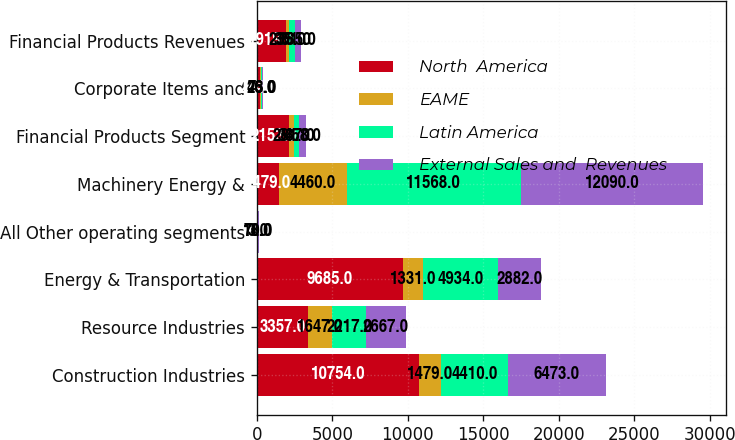Convert chart. <chart><loc_0><loc_0><loc_500><loc_500><stacked_bar_chart><ecel><fcel>Construction Industries<fcel>Resource Industries<fcel>Energy & Transportation<fcel>All Other operating segments<fcel>Machinery Energy &<fcel>Financial Products Segment<fcel>Corporate Items and<fcel>Financial Products Revenues<nl><fcel>North  America<fcel>10754<fcel>3357<fcel>9685<fcel>63<fcel>1479<fcel>2153<fcel>234<fcel>1919<nl><fcel>EAME<fcel>1479<fcel>1647<fcel>1331<fcel>3<fcel>4460<fcel>281<fcel>46<fcel>235<nl><fcel>Latin America<fcel>4410<fcel>2217<fcel>4934<fcel>18<fcel>11568<fcel>387<fcel>26<fcel>361<nl><fcel>External Sales and  Revenues<fcel>6473<fcel>2667<fcel>2882<fcel>70<fcel>12090<fcel>458<fcel>73<fcel>385<nl></chart> 